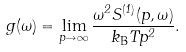Convert formula to latex. <formula><loc_0><loc_0><loc_500><loc_500>g ( \omega ) = \lim _ { p \to \infty } \frac { \omega ^ { 2 } S ^ { ( 1 ) } ( p , \omega ) } { k _ { \mathrm B } T p ^ { 2 } } .</formula> 